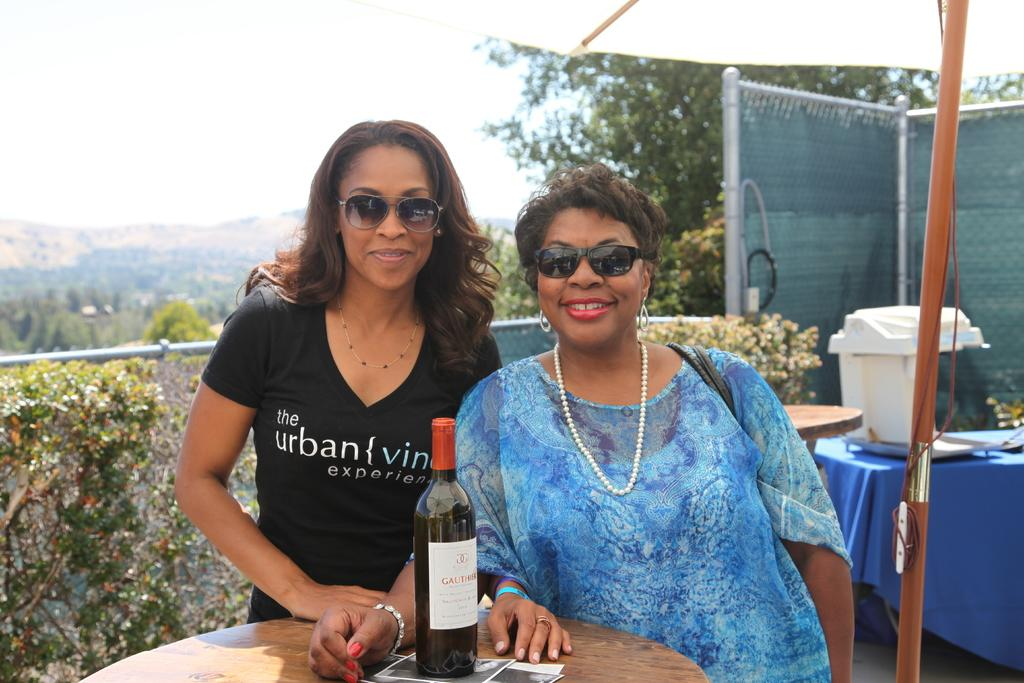How many women are in the image? There are two women in the image. What are the women doing in the image? The women are posing for a camera. What object is present on the table in front of the women? There is a champagne bottle on a table in front of the women. What type of apples are the women holding in the image? There are no apples present in the image; the women are posing for a camera and there is a champagne bottle on a table in front of them. Can you tell me if the women are crying in the image? There is no indication in the image that the women are crying; they are posing for a camera. 